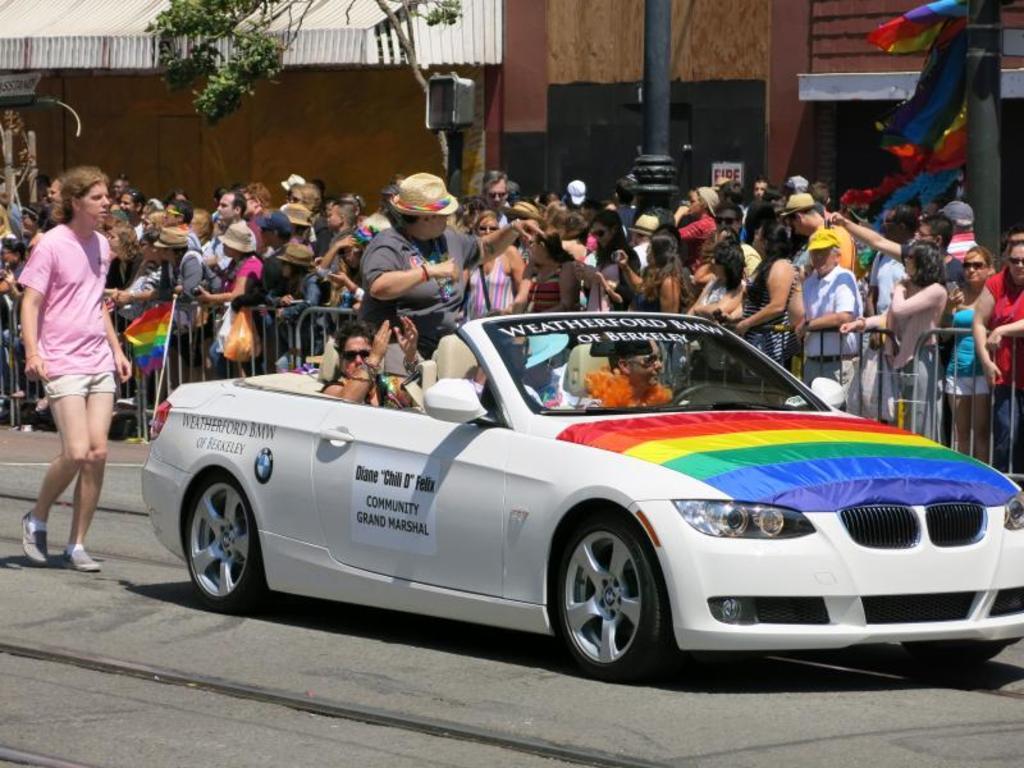How would you summarize this image in a sentence or two? In this image i can see a group of people are standing and i can also see there is a car on the road. 